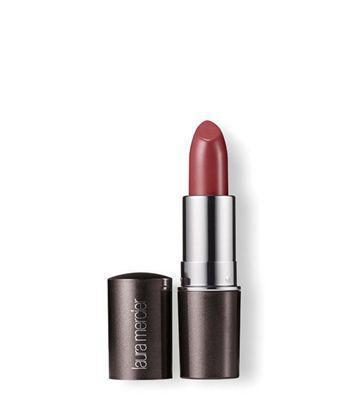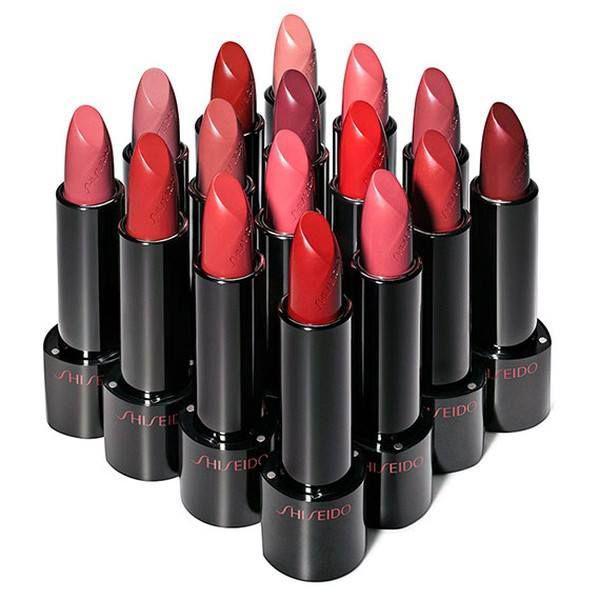The first image is the image on the left, the second image is the image on the right. Analyze the images presented: Is the assertion "The lipsticks are arranged in the shape of a diamond." valid? Answer yes or no. Yes. The first image is the image on the left, the second image is the image on the right. For the images displayed, is the sentence "There are sixteen lipsticks in the right image." factually correct? Answer yes or no. Yes. 